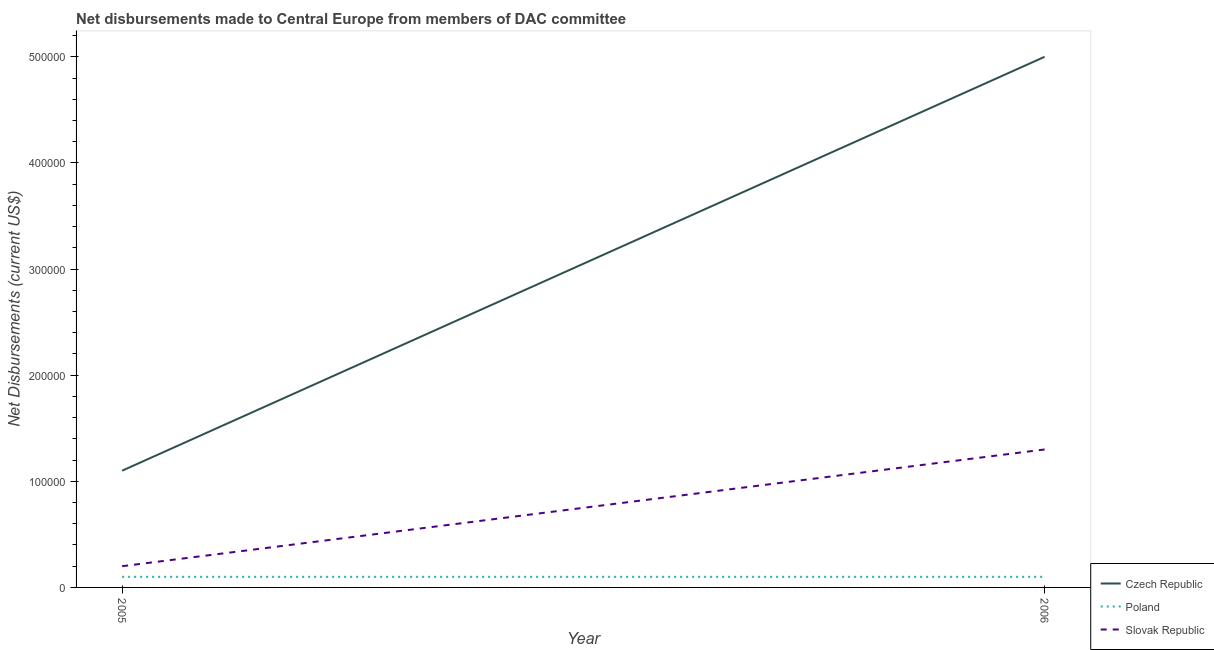Does the line corresponding to net disbursements made by poland intersect with the line corresponding to net disbursements made by slovak republic?
Offer a terse response. No. What is the net disbursements made by czech republic in 2006?
Your answer should be compact. 5.00e+05. Across all years, what is the maximum net disbursements made by poland?
Make the answer very short. 10000. Across all years, what is the minimum net disbursements made by czech republic?
Offer a terse response. 1.10e+05. In which year was the net disbursements made by slovak republic maximum?
Provide a short and direct response. 2006. What is the total net disbursements made by czech republic in the graph?
Provide a short and direct response. 6.10e+05. What is the difference between the net disbursements made by slovak republic in 2006 and the net disbursements made by czech republic in 2005?
Ensure brevity in your answer.  2.00e+04. What is the average net disbursements made by czech republic per year?
Offer a very short reply. 3.05e+05. In the year 2005, what is the difference between the net disbursements made by czech republic and net disbursements made by slovak republic?
Make the answer very short. 9.00e+04. In how many years, is the net disbursements made by poland greater than 360000 US$?
Provide a short and direct response. 0. What is the ratio of the net disbursements made by slovak republic in 2005 to that in 2006?
Offer a terse response. 0.15. Is the net disbursements made by poland in 2005 less than that in 2006?
Your response must be concise. No. In how many years, is the net disbursements made by czech republic greater than the average net disbursements made by czech republic taken over all years?
Your response must be concise. 1. Does the net disbursements made by czech republic monotonically increase over the years?
Offer a very short reply. Yes. Is the net disbursements made by czech republic strictly greater than the net disbursements made by poland over the years?
Your response must be concise. Yes. Is the net disbursements made by czech republic strictly less than the net disbursements made by slovak republic over the years?
Offer a very short reply. No. How many lines are there?
Ensure brevity in your answer.  3. How many years are there in the graph?
Offer a terse response. 2. What is the difference between two consecutive major ticks on the Y-axis?
Your answer should be very brief. 1.00e+05. Are the values on the major ticks of Y-axis written in scientific E-notation?
Give a very brief answer. No. Where does the legend appear in the graph?
Your response must be concise. Bottom right. What is the title of the graph?
Your answer should be very brief. Net disbursements made to Central Europe from members of DAC committee. Does "Male employers" appear as one of the legend labels in the graph?
Your response must be concise. No. What is the label or title of the X-axis?
Offer a very short reply. Year. What is the label or title of the Y-axis?
Your answer should be very brief. Net Disbursements (current US$). What is the Net Disbursements (current US$) in Slovak Republic in 2006?
Offer a terse response. 1.30e+05. Across all years, what is the maximum Net Disbursements (current US$) in Slovak Republic?
Keep it short and to the point. 1.30e+05. What is the total Net Disbursements (current US$) in Poland in the graph?
Provide a succinct answer. 2.00e+04. What is the total Net Disbursements (current US$) of Slovak Republic in the graph?
Provide a succinct answer. 1.50e+05. What is the difference between the Net Disbursements (current US$) in Czech Republic in 2005 and that in 2006?
Your answer should be very brief. -3.90e+05. What is the difference between the Net Disbursements (current US$) in Slovak Republic in 2005 and that in 2006?
Offer a very short reply. -1.10e+05. What is the difference between the Net Disbursements (current US$) of Czech Republic in 2005 and the Net Disbursements (current US$) of Poland in 2006?
Provide a short and direct response. 1.00e+05. What is the average Net Disbursements (current US$) of Czech Republic per year?
Give a very brief answer. 3.05e+05. What is the average Net Disbursements (current US$) in Poland per year?
Ensure brevity in your answer.  10000. What is the average Net Disbursements (current US$) of Slovak Republic per year?
Give a very brief answer. 7.50e+04. In the year 2005, what is the difference between the Net Disbursements (current US$) in Czech Republic and Net Disbursements (current US$) in Poland?
Offer a very short reply. 1.00e+05. In the year 2005, what is the difference between the Net Disbursements (current US$) in Czech Republic and Net Disbursements (current US$) in Slovak Republic?
Make the answer very short. 9.00e+04. In the year 2006, what is the difference between the Net Disbursements (current US$) in Czech Republic and Net Disbursements (current US$) in Slovak Republic?
Provide a succinct answer. 3.70e+05. In the year 2006, what is the difference between the Net Disbursements (current US$) in Poland and Net Disbursements (current US$) in Slovak Republic?
Provide a succinct answer. -1.20e+05. What is the ratio of the Net Disbursements (current US$) of Czech Republic in 2005 to that in 2006?
Offer a terse response. 0.22. What is the ratio of the Net Disbursements (current US$) of Slovak Republic in 2005 to that in 2006?
Make the answer very short. 0.15. What is the difference between the highest and the second highest Net Disbursements (current US$) in Czech Republic?
Give a very brief answer. 3.90e+05. What is the difference between the highest and the lowest Net Disbursements (current US$) in Poland?
Ensure brevity in your answer.  0. What is the difference between the highest and the lowest Net Disbursements (current US$) in Slovak Republic?
Make the answer very short. 1.10e+05. 